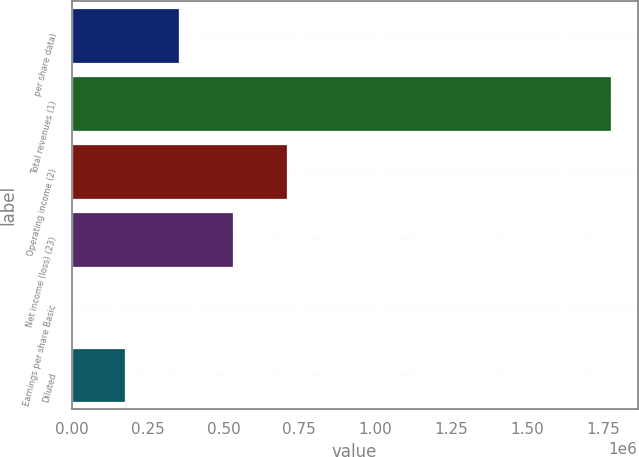Convert chart to OTSL. <chart><loc_0><loc_0><loc_500><loc_500><bar_chart><fcel>per share data)<fcel>Total revenues (1)<fcel>Operating income (2)<fcel>Net income (loss) (23)<fcel>Earnings per share Basic<fcel>Diluted<nl><fcel>355080<fcel>1.7754e+06<fcel>710160<fcel>532620<fcel>0.17<fcel>177540<nl></chart> 